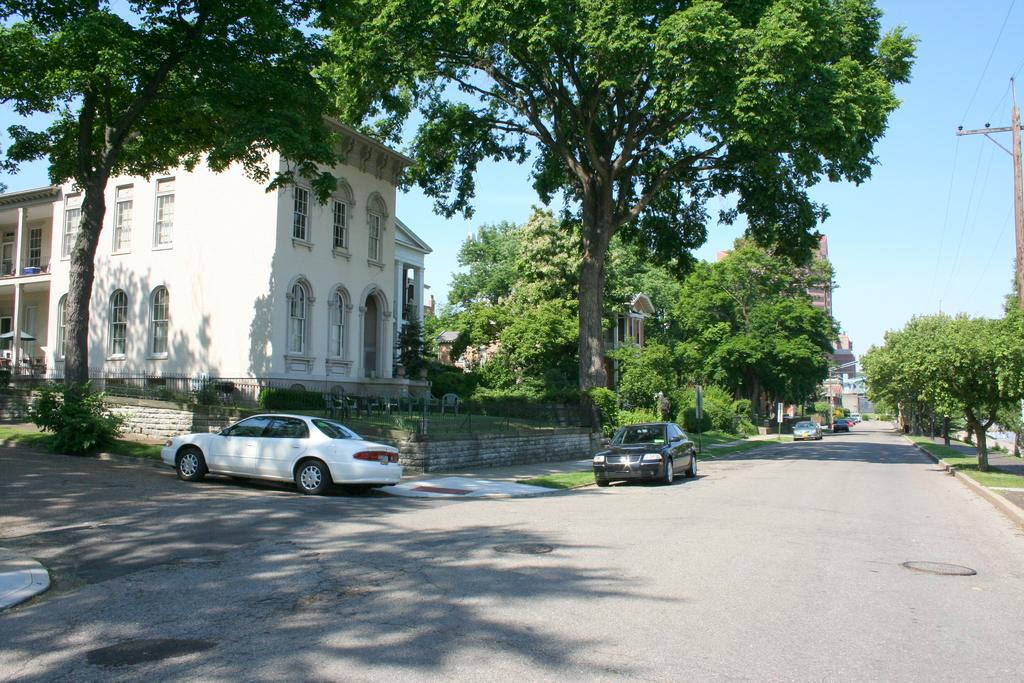What can be seen on the road in the image? There are vehicles on the road in the image. What structures are present in the image? There is a wall, a fence, buildings with windows, and a pole in the image. What type of vegetation is visible in the image? There are trees in the image. What is on the grass in the image? There are chairs on the grass in the image. What is visible in the background of the image? The sky is visible in the background of the image. Can you see any stars in the image? There are no stars visible in the image; only the sky is visible in the background. Is there an ocean present in the image? There is no ocean present in the image; it features a road, vehicles, and other structures and objects. 